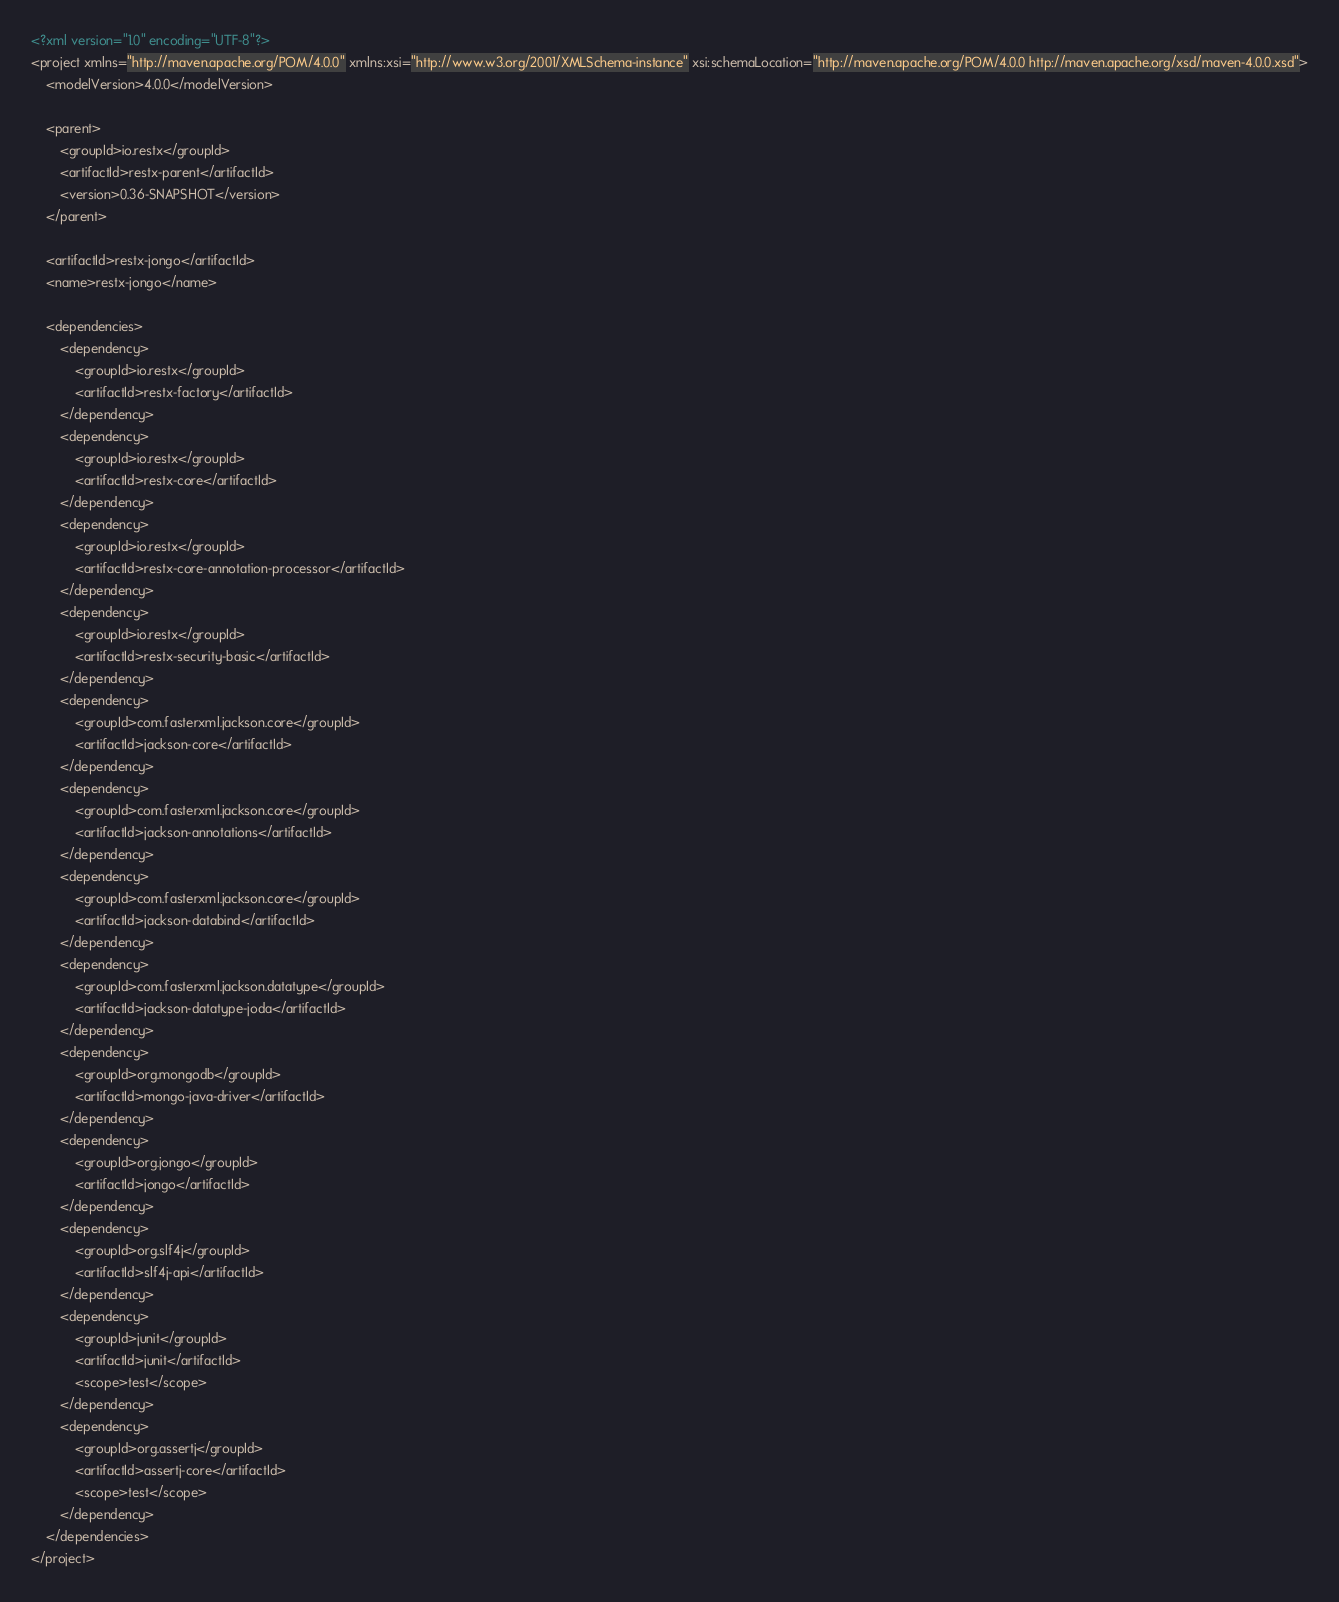<code> <loc_0><loc_0><loc_500><loc_500><_XML_><?xml version="1.0" encoding="UTF-8"?>
<project xmlns="http://maven.apache.org/POM/4.0.0" xmlns:xsi="http://www.w3.org/2001/XMLSchema-instance" xsi:schemaLocation="http://maven.apache.org/POM/4.0.0 http://maven.apache.org/xsd/maven-4.0.0.xsd">
    <modelVersion>4.0.0</modelVersion>

    <parent>
        <groupId>io.restx</groupId>
        <artifactId>restx-parent</artifactId>
        <version>0.36-SNAPSHOT</version>
    </parent>

    <artifactId>restx-jongo</artifactId>
    <name>restx-jongo</name>

    <dependencies>
        <dependency>
            <groupId>io.restx</groupId>
            <artifactId>restx-factory</artifactId>
        </dependency>
        <dependency>
            <groupId>io.restx</groupId>
            <artifactId>restx-core</artifactId>
        </dependency>
        <dependency>
            <groupId>io.restx</groupId>
            <artifactId>restx-core-annotation-processor</artifactId>
        </dependency>
        <dependency>
            <groupId>io.restx</groupId>
            <artifactId>restx-security-basic</artifactId>
        </dependency>
        <dependency>
            <groupId>com.fasterxml.jackson.core</groupId>
            <artifactId>jackson-core</artifactId>
        </dependency>
        <dependency>
            <groupId>com.fasterxml.jackson.core</groupId>
            <artifactId>jackson-annotations</artifactId>
        </dependency>
        <dependency>
            <groupId>com.fasterxml.jackson.core</groupId>
            <artifactId>jackson-databind</artifactId>
        </dependency>
        <dependency>
            <groupId>com.fasterxml.jackson.datatype</groupId>
            <artifactId>jackson-datatype-joda</artifactId>
        </dependency>
        <dependency>
            <groupId>org.mongodb</groupId>
            <artifactId>mongo-java-driver</artifactId>
        </dependency>
        <dependency>
            <groupId>org.jongo</groupId>
            <artifactId>jongo</artifactId>
        </dependency>
        <dependency>
            <groupId>org.slf4j</groupId>
            <artifactId>slf4j-api</artifactId>
        </dependency>
        <dependency>
            <groupId>junit</groupId>
            <artifactId>junit</artifactId>
            <scope>test</scope>
        </dependency>
        <dependency>
            <groupId>org.assertj</groupId>
            <artifactId>assertj-core</artifactId>
            <scope>test</scope>
        </dependency>
    </dependencies>
</project>
</code> 